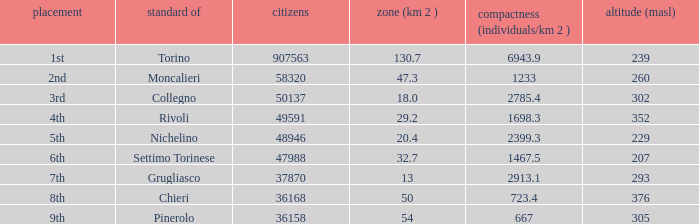How many altitudes does the common with an area of 130.7 km^2 have? 1.0. 